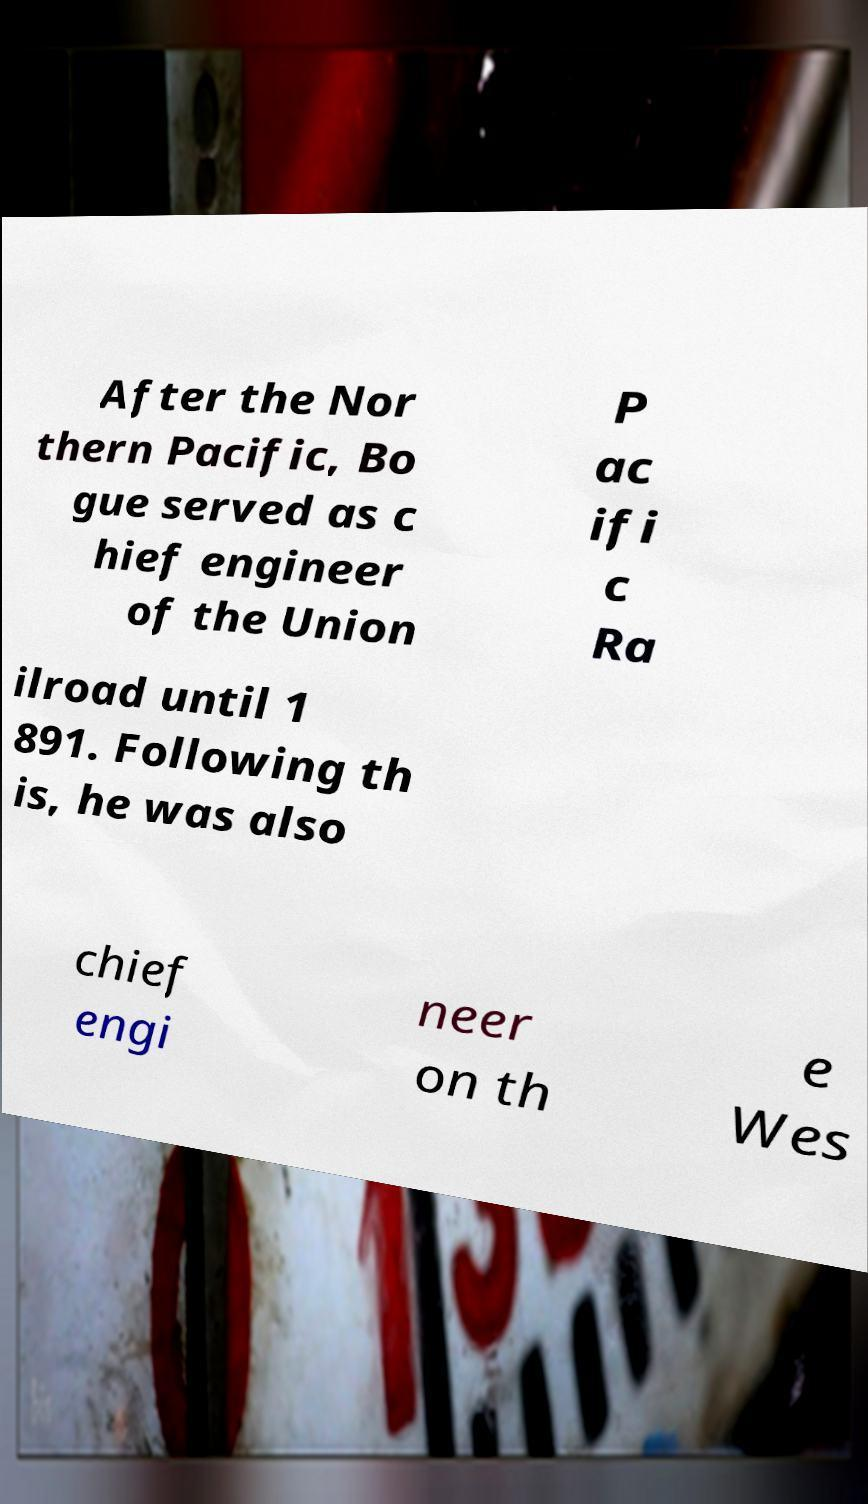Can you accurately transcribe the text from the provided image for me? After the Nor thern Pacific, Bo gue served as c hief engineer of the Union P ac ifi c Ra ilroad until 1 891. Following th is, he was also chief engi neer on th e Wes 